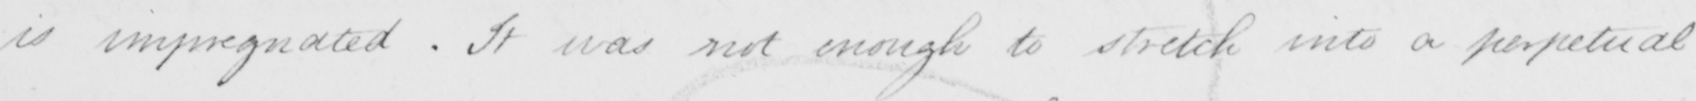Transcribe the text shown in this historical manuscript line. is impregnated . It was not enough to stretch into a perpetual 